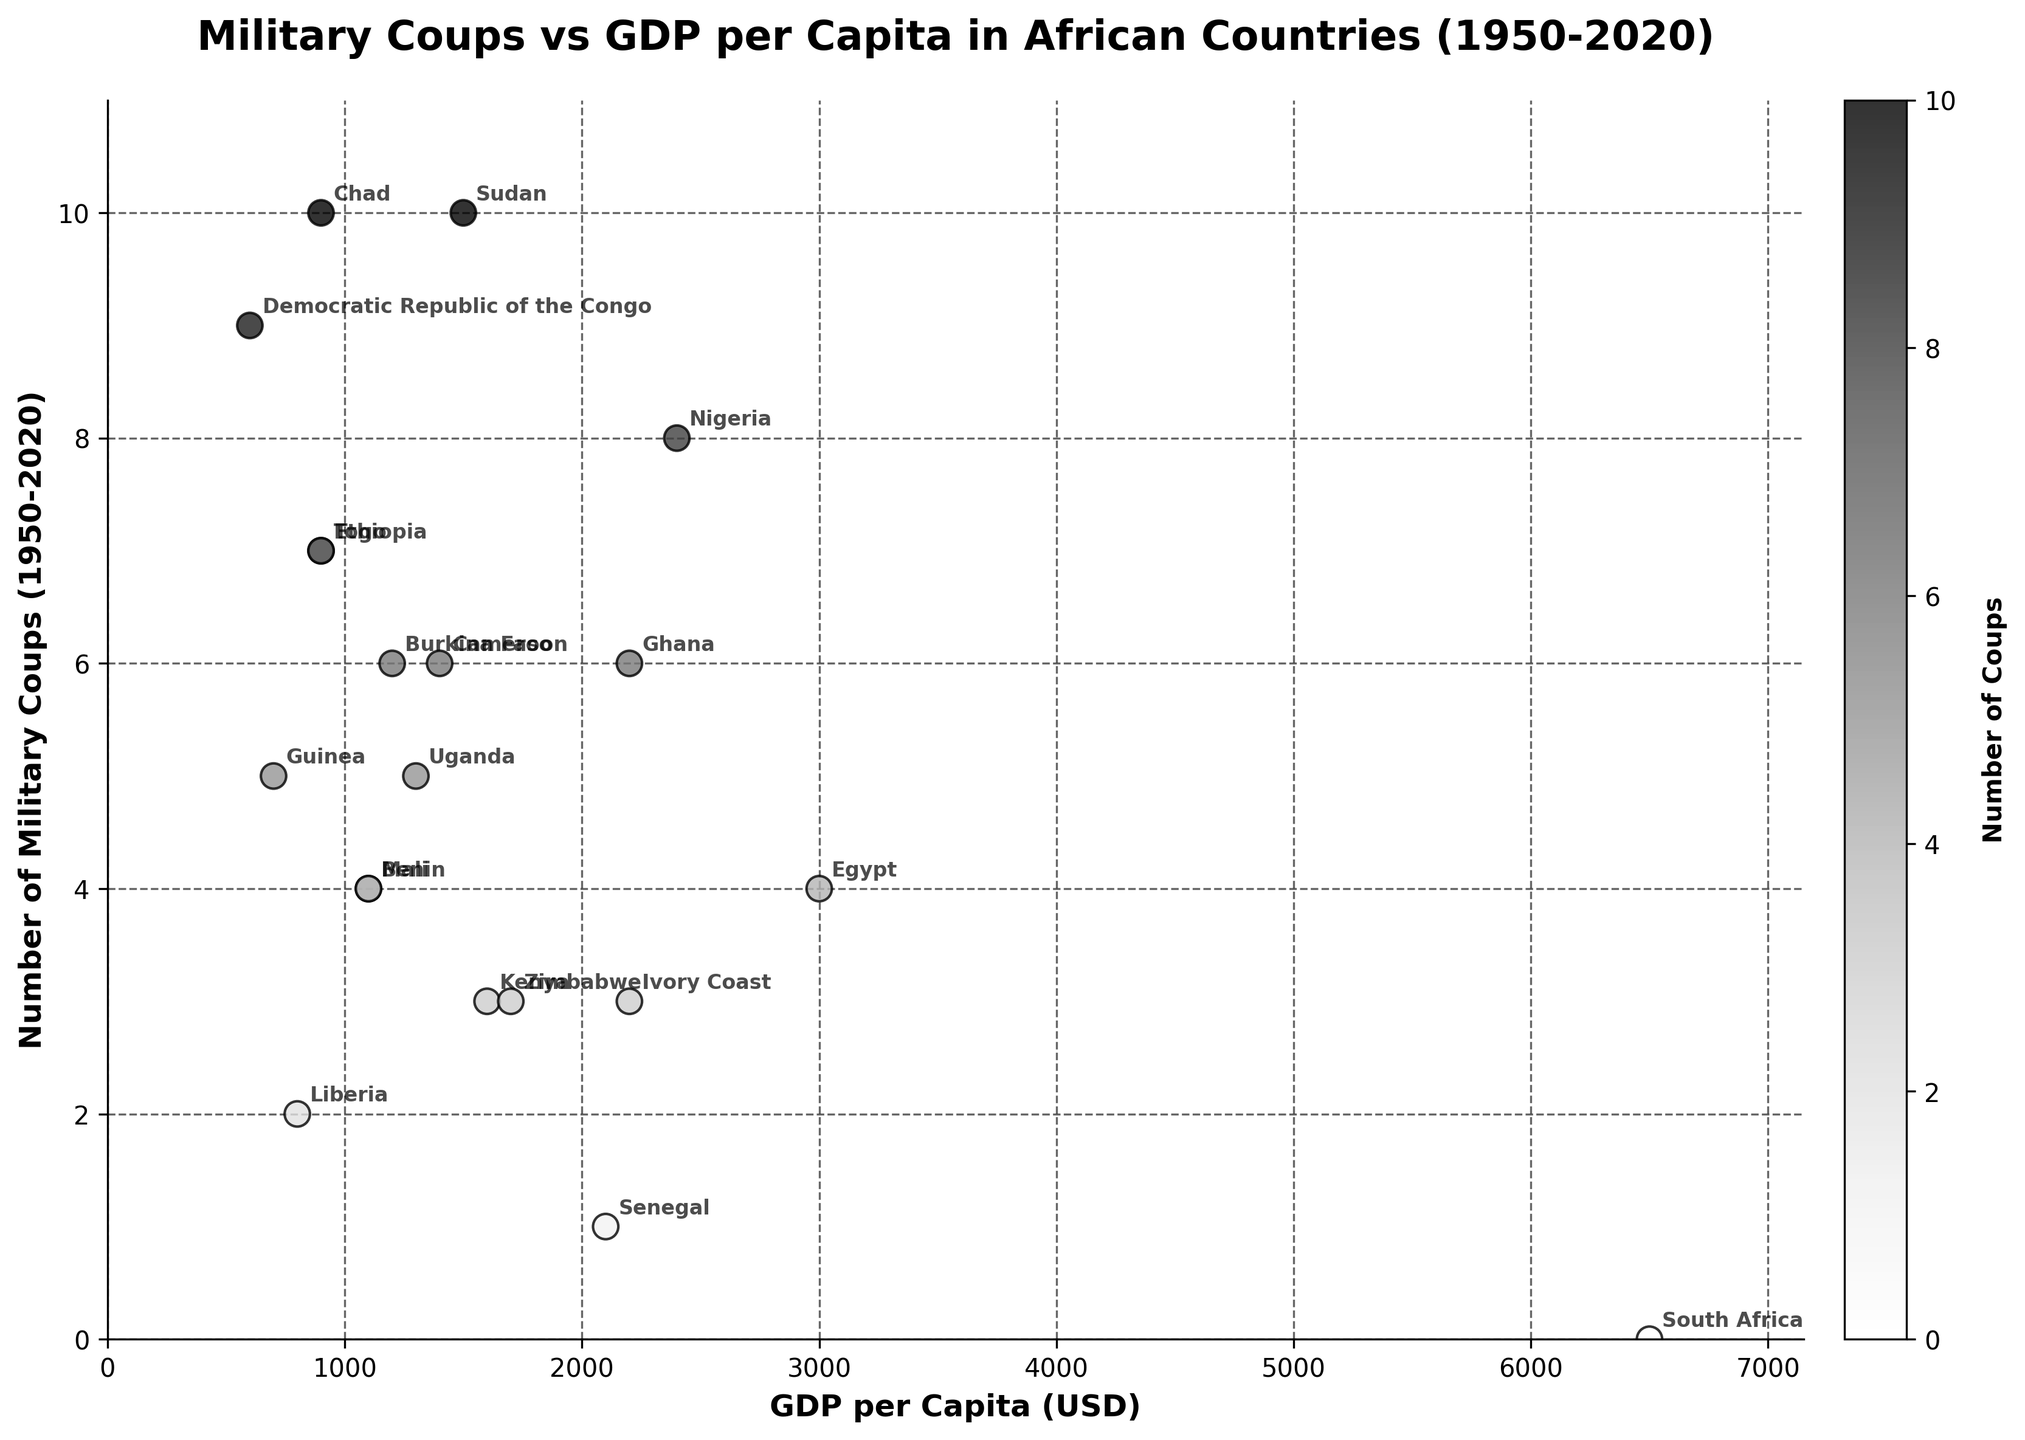What's the title of the plot? The title is the largest text at the top of the plot. It provides a summary of what the plot represents.
Answer: Military Coups vs GDP per Capita in African Countries (1950-2020) What is the country with the highest number of military coups? The country with the highest number of military coups is represented by the topmost data point on the y-axis.
Answer: Sudan How many countries have had exactly 6 military coups? Identify the data points that correspond to '6' on the y-axis, then count them.
Answer: 4 Which country has the highest GDP per capita and how many military coups did it have? The country with the highest GDP per capita is represented by the rightmost data point on the x-axis. Look for the country's name and its corresponding y-axis value.
Answer: South Africa, 0 What's the relationship between GDP per capita and the number of military coups? Observe the general trend in the scatter plot: whether an increase in GDP per capita correlates with an increase or decrease in the number of military coups.
Answer: Generally, higher GDP per capita correlates with fewer military coups Which country had 4 military coups and what is its GDP per capita? Look for the data points that correspond to '4' on the y-axis, find the country name next to it, and check its x-axis value.
Answer: Egypt, 3000 Aggregate the number of military coups for countries with a GDP per Capita less than 1000 USD. What is the sum? Identify and sum the y-axis values for the countries with x-axis values (GDP per capita) less than 1000 USD.
Answer: 49 What is the average GDP per capita for countries that had more than 5 military coups? Identify the countries with more than 5 coups, sum their GDP per capita values, and divide by the number of those countries.
Answer: 1025 Which country closest to the median GDP per capita has had the fewest military coups? First, find the median GDP per capita by listing all GDP values in order, identify the middle value, then check the military coups for that country.
Answer: Benin, 4 How does the number of military coups in Ghana compare to the number in Nigeria? Locate the points for Ghana and Nigeria and compare their y-axis values.
Answer: Ghana has 2 fewer coups than Nigeria 